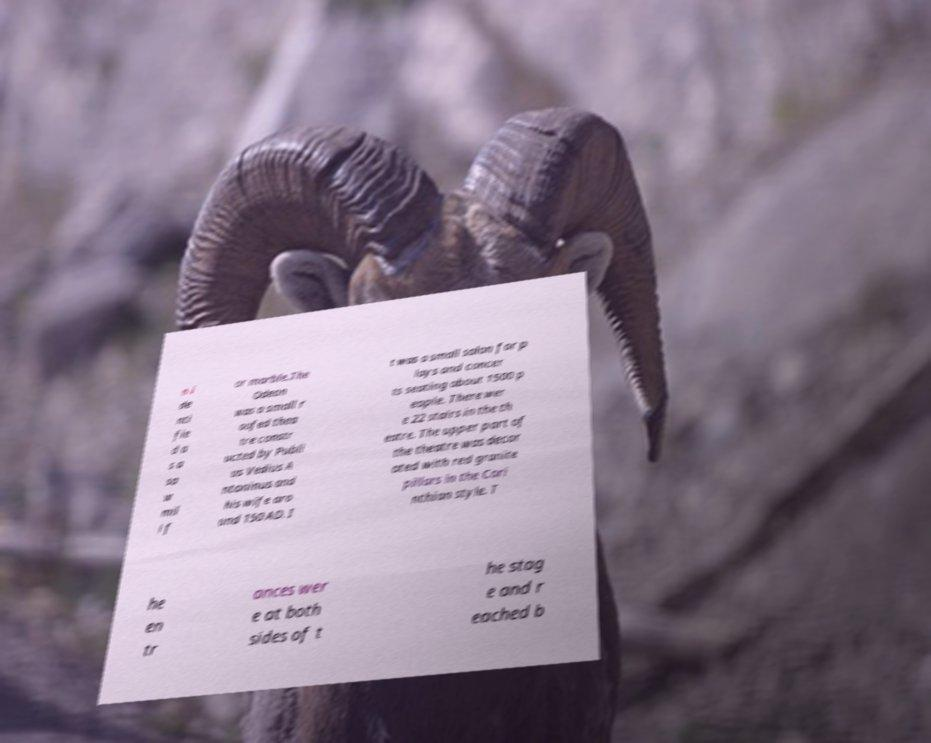Can you read and provide the text displayed in the image?This photo seems to have some interesting text. Can you extract and type it out for me? n i de nti fie d a s a sa w mil l f or marble.The Odeon was a small r oofed thea tre constr ucted by Publi us Vedius A ntoninus and his wife aro und 150 AD. I t was a small salon for p lays and concer ts seating about 1500 p eople. There wer e 22 stairs in the th eatre. The upper part of the theatre was decor ated with red granite pillars in the Cori nthian style. T he en tr ances wer e at both sides of t he stag e and r eached b 